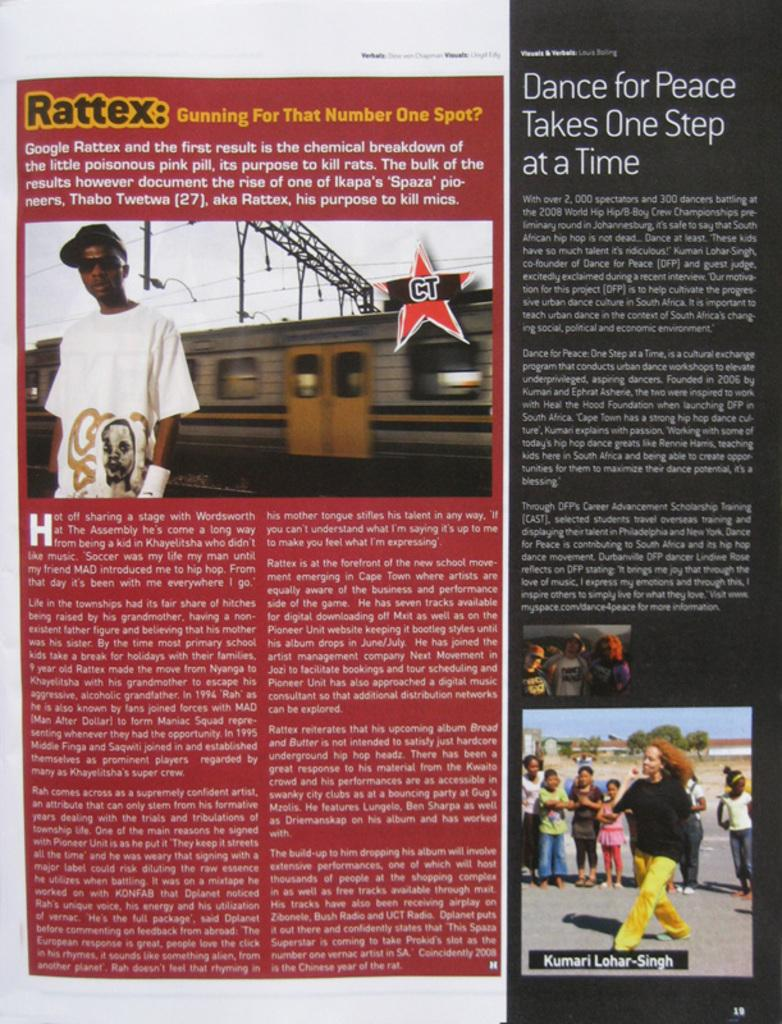What type of content is present in the magazine article? The magazine article contains text and pictures. What subjects are depicted in the pictures within the magazine article? The pictures in the magazine article contain images of people, a train, metal rods, cables, trees, and buildings. Can you describe the setting of the train in the magazine article? The train is depicted in the context of its surroundings, which include trees and buildings. How many boys are present in the magazine article? There is no mention of boys in the magazine article; it contains pictures of people, but their gender is not specified. What type of mint is used to flavor the train in the magazine article? There is no mention of mint or any flavoring in the magazine article; it contains pictures of a train in its surroundings. 